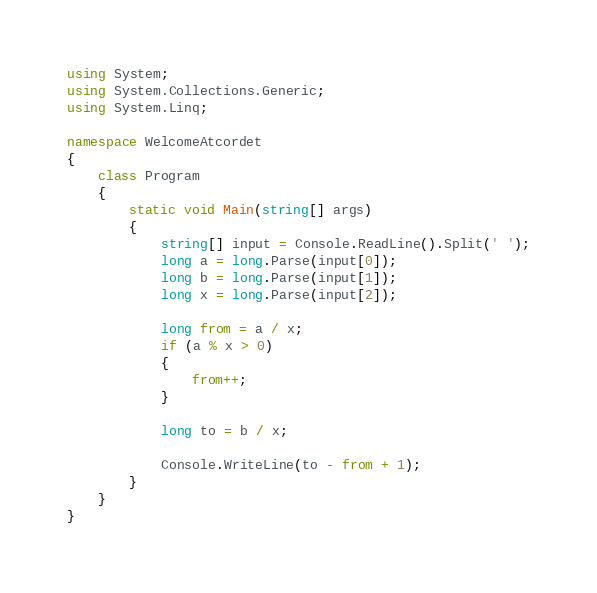<code> <loc_0><loc_0><loc_500><loc_500><_C#_>using System;
using System.Collections.Generic;
using System.Linq;

namespace WelcomeAtcordet
{
    class Program
    {
        static void Main(string[] args)
        {
            string[] input = Console.ReadLine().Split(' ');
            long a = long.Parse(input[0]);
            long b = long.Parse(input[1]);
            long x = long.Parse(input[2]);

            long from = a / x;
            if (a % x > 0)
            {
                from++;
            }

            long to = b / x;

            Console.WriteLine(to - from + 1);
        }
    }
}
</code> 